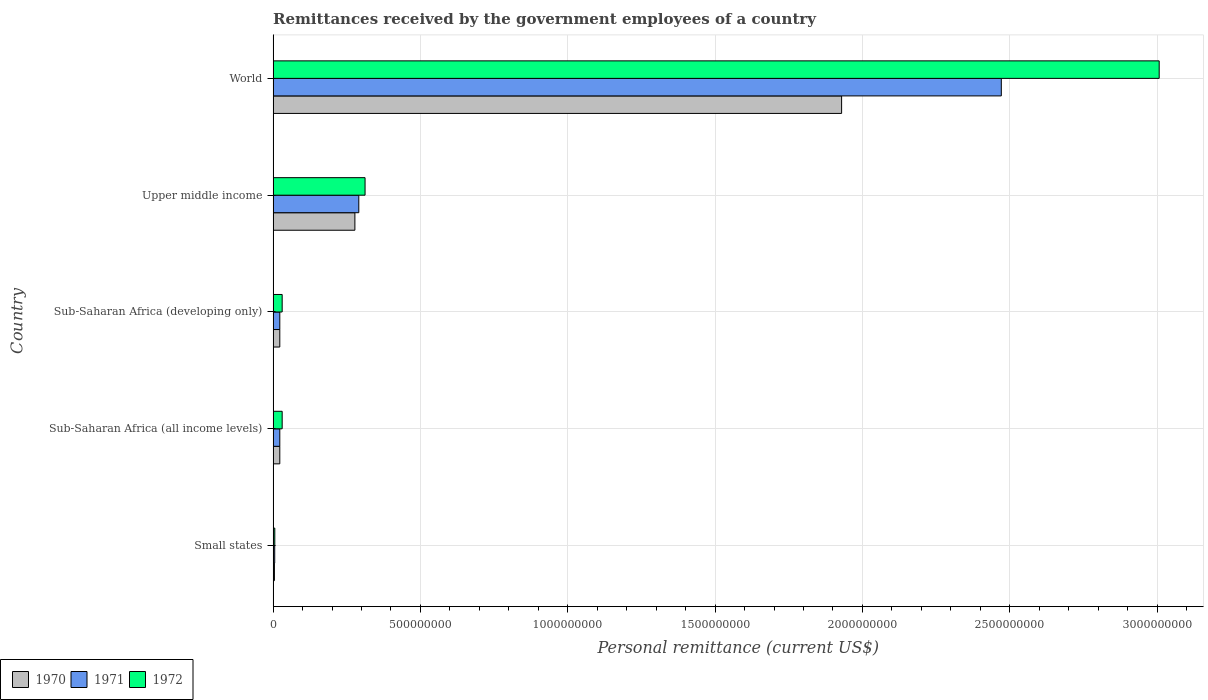How many different coloured bars are there?
Your response must be concise. 3. How many groups of bars are there?
Keep it short and to the point. 5. Are the number of bars per tick equal to the number of legend labels?
Your answer should be compact. Yes. Are the number of bars on each tick of the Y-axis equal?
Your response must be concise. Yes. How many bars are there on the 2nd tick from the bottom?
Give a very brief answer. 3. What is the remittances received by the government employees in 1971 in Upper middle income?
Provide a succinct answer. 2.91e+08. Across all countries, what is the maximum remittances received by the government employees in 1972?
Offer a terse response. 3.01e+09. Across all countries, what is the minimum remittances received by the government employees in 1970?
Make the answer very short. 4.40e+06. In which country was the remittances received by the government employees in 1972 maximum?
Give a very brief answer. World. In which country was the remittances received by the government employees in 1971 minimum?
Give a very brief answer. Small states. What is the total remittances received by the government employees in 1972 in the graph?
Provide a succinct answer. 3.39e+09. What is the difference between the remittances received by the government employees in 1972 in Small states and that in Upper middle income?
Provide a short and direct response. -3.06e+08. What is the difference between the remittances received by the government employees in 1972 in Upper middle income and the remittances received by the government employees in 1970 in Small states?
Offer a very short reply. 3.08e+08. What is the average remittances received by the government employees in 1972 per country?
Keep it short and to the point. 6.77e+08. What is the difference between the remittances received by the government employees in 1970 and remittances received by the government employees in 1971 in Small states?
Offer a terse response. -1.00e+06. What is the ratio of the remittances received by the government employees in 1971 in Upper middle income to that in World?
Keep it short and to the point. 0.12. Is the difference between the remittances received by the government employees in 1970 in Upper middle income and World greater than the difference between the remittances received by the government employees in 1971 in Upper middle income and World?
Provide a succinct answer. Yes. What is the difference between the highest and the second highest remittances received by the government employees in 1970?
Provide a succinct answer. 1.65e+09. What is the difference between the highest and the lowest remittances received by the government employees in 1970?
Give a very brief answer. 1.92e+09. In how many countries, is the remittances received by the government employees in 1970 greater than the average remittances received by the government employees in 1970 taken over all countries?
Provide a short and direct response. 1. Is the sum of the remittances received by the government employees in 1972 in Sub-Saharan Africa (all income levels) and Sub-Saharan Africa (developing only) greater than the maximum remittances received by the government employees in 1970 across all countries?
Offer a very short reply. No. How many bars are there?
Give a very brief answer. 15. How many countries are there in the graph?
Make the answer very short. 5. Does the graph contain any zero values?
Provide a succinct answer. No. Where does the legend appear in the graph?
Provide a short and direct response. Bottom left. How are the legend labels stacked?
Ensure brevity in your answer.  Horizontal. What is the title of the graph?
Give a very brief answer. Remittances received by the government employees of a country. What is the label or title of the X-axis?
Your response must be concise. Personal remittance (current US$). What is the label or title of the Y-axis?
Your answer should be compact. Country. What is the Personal remittance (current US$) in 1970 in Small states?
Provide a short and direct response. 4.40e+06. What is the Personal remittance (current US$) of 1971 in Small states?
Your response must be concise. 5.40e+06. What is the Personal remittance (current US$) of 1972 in Small states?
Provide a short and direct response. 5.71e+06. What is the Personal remittance (current US$) of 1970 in Sub-Saharan Africa (all income levels)?
Offer a very short reply. 2.27e+07. What is the Personal remittance (current US$) in 1971 in Sub-Saharan Africa (all income levels)?
Ensure brevity in your answer.  2.26e+07. What is the Personal remittance (current US$) in 1972 in Sub-Saharan Africa (all income levels)?
Your answer should be compact. 3.07e+07. What is the Personal remittance (current US$) of 1970 in Sub-Saharan Africa (developing only)?
Make the answer very short. 2.27e+07. What is the Personal remittance (current US$) in 1971 in Sub-Saharan Africa (developing only)?
Offer a very short reply. 2.26e+07. What is the Personal remittance (current US$) of 1972 in Sub-Saharan Africa (developing only)?
Your answer should be very brief. 3.07e+07. What is the Personal remittance (current US$) of 1970 in Upper middle income?
Offer a very short reply. 2.77e+08. What is the Personal remittance (current US$) of 1971 in Upper middle income?
Give a very brief answer. 2.91e+08. What is the Personal remittance (current US$) of 1972 in Upper middle income?
Offer a very short reply. 3.12e+08. What is the Personal remittance (current US$) in 1970 in World?
Make the answer very short. 1.93e+09. What is the Personal remittance (current US$) in 1971 in World?
Offer a terse response. 2.47e+09. What is the Personal remittance (current US$) in 1972 in World?
Keep it short and to the point. 3.01e+09. Across all countries, what is the maximum Personal remittance (current US$) in 1970?
Keep it short and to the point. 1.93e+09. Across all countries, what is the maximum Personal remittance (current US$) in 1971?
Your response must be concise. 2.47e+09. Across all countries, what is the maximum Personal remittance (current US$) in 1972?
Ensure brevity in your answer.  3.01e+09. Across all countries, what is the minimum Personal remittance (current US$) in 1970?
Ensure brevity in your answer.  4.40e+06. Across all countries, what is the minimum Personal remittance (current US$) in 1971?
Offer a very short reply. 5.40e+06. Across all countries, what is the minimum Personal remittance (current US$) of 1972?
Keep it short and to the point. 5.71e+06. What is the total Personal remittance (current US$) in 1970 in the graph?
Offer a very short reply. 2.26e+09. What is the total Personal remittance (current US$) of 1971 in the graph?
Your answer should be compact. 2.81e+09. What is the total Personal remittance (current US$) in 1972 in the graph?
Offer a very short reply. 3.39e+09. What is the difference between the Personal remittance (current US$) in 1970 in Small states and that in Sub-Saharan Africa (all income levels)?
Provide a succinct answer. -1.83e+07. What is the difference between the Personal remittance (current US$) of 1971 in Small states and that in Sub-Saharan Africa (all income levels)?
Ensure brevity in your answer.  -1.72e+07. What is the difference between the Personal remittance (current US$) in 1972 in Small states and that in Sub-Saharan Africa (all income levels)?
Your answer should be compact. -2.50e+07. What is the difference between the Personal remittance (current US$) of 1970 in Small states and that in Sub-Saharan Africa (developing only)?
Make the answer very short. -1.83e+07. What is the difference between the Personal remittance (current US$) in 1971 in Small states and that in Sub-Saharan Africa (developing only)?
Offer a very short reply. -1.72e+07. What is the difference between the Personal remittance (current US$) in 1972 in Small states and that in Sub-Saharan Africa (developing only)?
Provide a short and direct response. -2.50e+07. What is the difference between the Personal remittance (current US$) in 1970 in Small states and that in Upper middle income?
Offer a terse response. -2.73e+08. What is the difference between the Personal remittance (current US$) of 1971 in Small states and that in Upper middle income?
Provide a short and direct response. -2.85e+08. What is the difference between the Personal remittance (current US$) in 1972 in Small states and that in Upper middle income?
Offer a very short reply. -3.06e+08. What is the difference between the Personal remittance (current US$) in 1970 in Small states and that in World?
Offer a very short reply. -1.92e+09. What is the difference between the Personal remittance (current US$) of 1971 in Small states and that in World?
Provide a short and direct response. -2.47e+09. What is the difference between the Personal remittance (current US$) in 1972 in Small states and that in World?
Provide a short and direct response. -3.00e+09. What is the difference between the Personal remittance (current US$) in 1970 in Sub-Saharan Africa (all income levels) and that in Sub-Saharan Africa (developing only)?
Offer a terse response. 0. What is the difference between the Personal remittance (current US$) in 1971 in Sub-Saharan Africa (all income levels) and that in Sub-Saharan Africa (developing only)?
Keep it short and to the point. 0. What is the difference between the Personal remittance (current US$) in 1972 in Sub-Saharan Africa (all income levels) and that in Sub-Saharan Africa (developing only)?
Make the answer very short. 0. What is the difference between the Personal remittance (current US$) of 1970 in Sub-Saharan Africa (all income levels) and that in Upper middle income?
Make the answer very short. -2.55e+08. What is the difference between the Personal remittance (current US$) in 1971 in Sub-Saharan Africa (all income levels) and that in Upper middle income?
Your answer should be compact. -2.68e+08. What is the difference between the Personal remittance (current US$) of 1972 in Sub-Saharan Africa (all income levels) and that in Upper middle income?
Keep it short and to the point. -2.81e+08. What is the difference between the Personal remittance (current US$) of 1970 in Sub-Saharan Africa (all income levels) and that in World?
Give a very brief answer. -1.91e+09. What is the difference between the Personal remittance (current US$) in 1971 in Sub-Saharan Africa (all income levels) and that in World?
Your answer should be compact. -2.45e+09. What is the difference between the Personal remittance (current US$) in 1972 in Sub-Saharan Africa (all income levels) and that in World?
Offer a very short reply. -2.98e+09. What is the difference between the Personal remittance (current US$) in 1970 in Sub-Saharan Africa (developing only) and that in Upper middle income?
Ensure brevity in your answer.  -2.55e+08. What is the difference between the Personal remittance (current US$) in 1971 in Sub-Saharan Africa (developing only) and that in Upper middle income?
Make the answer very short. -2.68e+08. What is the difference between the Personal remittance (current US$) of 1972 in Sub-Saharan Africa (developing only) and that in Upper middle income?
Provide a succinct answer. -2.81e+08. What is the difference between the Personal remittance (current US$) in 1970 in Sub-Saharan Africa (developing only) and that in World?
Keep it short and to the point. -1.91e+09. What is the difference between the Personal remittance (current US$) of 1971 in Sub-Saharan Africa (developing only) and that in World?
Provide a succinct answer. -2.45e+09. What is the difference between the Personal remittance (current US$) in 1972 in Sub-Saharan Africa (developing only) and that in World?
Provide a short and direct response. -2.98e+09. What is the difference between the Personal remittance (current US$) in 1970 in Upper middle income and that in World?
Offer a terse response. -1.65e+09. What is the difference between the Personal remittance (current US$) of 1971 in Upper middle income and that in World?
Your response must be concise. -2.18e+09. What is the difference between the Personal remittance (current US$) in 1972 in Upper middle income and that in World?
Ensure brevity in your answer.  -2.70e+09. What is the difference between the Personal remittance (current US$) in 1970 in Small states and the Personal remittance (current US$) in 1971 in Sub-Saharan Africa (all income levels)?
Offer a very short reply. -1.82e+07. What is the difference between the Personal remittance (current US$) of 1970 in Small states and the Personal remittance (current US$) of 1972 in Sub-Saharan Africa (all income levels)?
Your answer should be very brief. -2.63e+07. What is the difference between the Personal remittance (current US$) of 1971 in Small states and the Personal remittance (current US$) of 1972 in Sub-Saharan Africa (all income levels)?
Ensure brevity in your answer.  -2.53e+07. What is the difference between the Personal remittance (current US$) of 1970 in Small states and the Personal remittance (current US$) of 1971 in Sub-Saharan Africa (developing only)?
Provide a succinct answer. -1.82e+07. What is the difference between the Personal remittance (current US$) in 1970 in Small states and the Personal remittance (current US$) in 1972 in Sub-Saharan Africa (developing only)?
Offer a terse response. -2.63e+07. What is the difference between the Personal remittance (current US$) in 1971 in Small states and the Personal remittance (current US$) in 1972 in Sub-Saharan Africa (developing only)?
Ensure brevity in your answer.  -2.53e+07. What is the difference between the Personal remittance (current US$) of 1970 in Small states and the Personal remittance (current US$) of 1971 in Upper middle income?
Your response must be concise. -2.86e+08. What is the difference between the Personal remittance (current US$) in 1970 in Small states and the Personal remittance (current US$) in 1972 in Upper middle income?
Your answer should be very brief. -3.08e+08. What is the difference between the Personal remittance (current US$) in 1971 in Small states and the Personal remittance (current US$) in 1972 in Upper middle income?
Keep it short and to the point. -3.07e+08. What is the difference between the Personal remittance (current US$) in 1970 in Small states and the Personal remittance (current US$) in 1971 in World?
Your answer should be compact. -2.47e+09. What is the difference between the Personal remittance (current US$) of 1970 in Small states and the Personal remittance (current US$) of 1972 in World?
Provide a short and direct response. -3.00e+09. What is the difference between the Personal remittance (current US$) in 1971 in Small states and the Personal remittance (current US$) in 1972 in World?
Your answer should be compact. -3.00e+09. What is the difference between the Personal remittance (current US$) in 1970 in Sub-Saharan Africa (all income levels) and the Personal remittance (current US$) in 1971 in Sub-Saharan Africa (developing only)?
Your answer should be compact. 2.18e+04. What is the difference between the Personal remittance (current US$) in 1970 in Sub-Saharan Africa (all income levels) and the Personal remittance (current US$) in 1972 in Sub-Saharan Africa (developing only)?
Give a very brief answer. -8.07e+06. What is the difference between the Personal remittance (current US$) of 1971 in Sub-Saharan Africa (all income levels) and the Personal remittance (current US$) of 1972 in Sub-Saharan Africa (developing only)?
Offer a very short reply. -8.09e+06. What is the difference between the Personal remittance (current US$) of 1970 in Sub-Saharan Africa (all income levels) and the Personal remittance (current US$) of 1971 in Upper middle income?
Your response must be concise. -2.68e+08. What is the difference between the Personal remittance (current US$) of 1970 in Sub-Saharan Africa (all income levels) and the Personal remittance (current US$) of 1972 in Upper middle income?
Give a very brief answer. -2.89e+08. What is the difference between the Personal remittance (current US$) of 1971 in Sub-Saharan Africa (all income levels) and the Personal remittance (current US$) of 1972 in Upper middle income?
Offer a terse response. -2.89e+08. What is the difference between the Personal remittance (current US$) of 1970 in Sub-Saharan Africa (all income levels) and the Personal remittance (current US$) of 1971 in World?
Ensure brevity in your answer.  -2.45e+09. What is the difference between the Personal remittance (current US$) of 1970 in Sub-Saharan Africa (all income levels) and the Personal remittance (current US$) of 1972 in World?
Offer a terse response. -2.98e+09. What is the difference between the Personal remittance (current US$) of 1971 in Sub-Saharan Africa (all income levels) and the Personal remittance (current US$) of 1972 in World?
Provide a succinct answer. -2.98e+09. What is the difference between the Personal remittance (current US$) of 1970 in Sub-Saharan Africa (developing only) and the Personal remittance (current US$) of 1971 in Upper middle income?
Keep it short and to the point. -2.68e+08. What is the difference between the Personal remittance (current US$) in 1970 in Sub-Saharan Africa (developing only) and the Personal remittance (current US$) in 1972 in Upper middle income?
Make the answer very short. -2.89e+08. What is the difference between the Personal remittance (current US$) of 1971 in Sub-Saharan Africa (developing only) and the Personal remittance (current US$) of 1972 in Upper middle income?
Ensure brevity in your answer.  -2.89e+08. What is the difference between the Personal remittance (current US$) of 1970 in Sub-Saharan Africa (developing only) and the Personal remittance (current US$) of 1971 in World?
Your answer should be compact. -2.45e+09. What is the difference between the Personal remittance (current US$) in 1970 in Sub-Saharan Africa (developing only) and the Personal remittance (current US$) in 1972 in World?
Offer a very short reply. -2.98e+09. What is the difference between the Personal remittance (current US$) in 1971 in Sub-Saharan Africa (developing only) and the Personal remittance (current US$) in 1972 in World?
Ensure brevity in your answer.  -2.98e+09. What is the difference between the Personal remittance (current US$) in 1970 in Upper middle income and the Personal remittance (current US$) in 1971 in World?
Your answer should be very brief. -2.19e+09. What is the difference between the Personal remittance (current US$) in 1970 in Upper middle income and the Personal remittance (current US$) in 1972 in World?
Provide a short and direct response. -2.73e+09. What is the difference between the Personal remittance (current US$) of 1971 in Upper middle income and the Personal remittance (current US$) of 1972 in World?
Keep it short and to the point. -2.72e+09. What is the average Personal remittance (current US$) of 1970 per country?
Your answer should be compact. 4.51e+08. What is the average Personal remittance (current US$) of 1971 per country?
Ensure brevity in your answer.  5.63e+08. What is the average Personal remittance (current US$) of 1972 per country?
Your answer should be very brief. 6.77e+08. What is the difference between the Personal remittance (current US$) of 1970 and Personal remittance (current US$) of 1971 in Small states?
Give a very brief answer. -1.00e+06. What is the difference between the Personal remittance (current US$) in 1970 and Personal remittance (current US$) in 1972 in Small states?
Offer a terse response. -1.31e+06. What is the difference between the Personal remittance (current US$) of 1971 and Personal remittance (current US$) of 1972 in Small states?
Your answer should be compact. -3.07e+05. What is the difference between the Personal remittance (current US$) in 1970 and Personal remittance (current US$) in 1971 in Sub-Saharan Africa (all income levels)?
Offer a terse response. 2.18e+04. What is the difference between the Personal remittance (current US$) in 1970 and Personal remittance (current US$) in 1972 in Sub-Saharan Africa (all income levels)?
Offer a terse response. -8.07e+06. What is the difference between the Personal remittance (current US$) in 1971 and Personal remittance (current US$) in 1972 in Sub-Saharan Africa (all income levels)?
Offer a terse response. -8.09e+06. What is the difference between the Personal remittance (current US$) in 1970 and Personal remittance (current US$) in 1971 in Sub-Saharan Africa (developing only)?
Your response must be concise. 2.18e+04. What is the difference between the Personal remittance (current US$) in 1970 and Personal remittance (current US$) in 1972 in Sub-Saharan Africa (developing only)?
Give a very brief answer. -8.07e+06. What is the difference between the Personal remittance (current US$) in 1971 and Personal remittance (current US$) in 1972 in Sub-Saharan Africa (developing only)?
Provide a succinct answer. -8.09e+06. What is the difference between the Personal remittance (current US$) in 1970 and Personal remittance (current US$) in 1971 in Upper middle income?
Your answer should be compact. -1.32e+07. What is the difference between the Personal remittance (current US$) in 1970 and Personal remittance (current US$) in 1972 in Upper middle income?
Your answer should be compact. -3.45e+07. What is the difference between the Personal remittance (current US$) of 1971 and Personal remittance (current US$) of 1972 in Upper middle income?
Offer a very short reply. -2.13e+07. What is the difference between the Personal remittance (current US$) of 1970 and Personal remittance (current US$) of 1971 in World?
Your answer should be very brief. -5.42e+08. What is the difference between the Personal remittance (current US$) of 1970 and Personal remittance (current US$) of 1972 in World?
Keep it short and to the point. -1.08e+09. What is the difference between the Personal remittance (current US$) of 1971 and Personal remittance (current US$) of 1972 in World?
Your answer should be very brief. -5.36e+08. What is the ratio of the Personal remittance (current US$) of 1970 in Small states to that in Sub-Saharan Africa (all income levels)?
Provide a short and direct response. 0.19. What is the ratio of the Personal remittance (current US$) in 1971 in Small states to that in Sub-Saharan Africa (all income levels)?
Offer a very short reply. 0.24. What is the ratio of the Personal remittance (current US$) in 1972 in Small states to that in Sub-Saharan Africa (all income levels)?
Ensure brevity in your answer.  0.19. What is the ratio of the Personal remittance (current US$) of 1970 in Small states to that in Sub-Saharan Africa (developing only)?
Your answer should be very brief. 0.19. What is the ratio of the Personal remittance (current US$) of 1971 in Small states to that in Sub-Saharan Africa (developing only)?
Provide a succinct answer. 0.24. What is the ratio of the Personal remittance (current US$) of 1972 in Small states to that in Sub-Saharan Africa (developing only)?
Offer a very short reply. 0.19. What is the ratio of the Personal remittance (current US$) in 1970 in Small states to that in Upper middle income?
Offer a terse response. 0.02. What is the ratio of the Personal remittance (current US$) in 1971 in Small states to that in Upper middle income?
Your answer should be compact. 0.02. What is the ratio of the Personal remittance (current US$) in 1972 in Small states to that in Upper middle income?
Provide a succinct answer. 0.02. What is the ratio of the Personal remittance (current US$) of 1970 in Small states to that in World?
Your answer should be compact. 0. What is the ratio of the Personal remittance (current US$) of 1971 in Small states to that in World?
Make the answer very short. 0. What is the ratio of the Personal remittance (current US$) in 1972 in Small states to that in World?
Give a very brief answer. 0. What is the ratio of the Personal remittance (current US$) of 1970 in Sub-Saharan Africa (all income levels) to that in Upper middle income?
Provide a succinct answer. 0.08. What is the ratio of the Personal remittance (current US$) in 1971 in Sub-Saharan Africa (all income levels) to that in Upper middle income?
Your answer should be very brief. 0.08. What is the ratio of the Personal remittance (current US$) in 1972 in Sub-Saharan Africa (all income levels) to that in Upper middle income?
Keep it short and to the point. 0.1. What is the ratio of the Personal remittance (current US$) in 1970 in Sub-Saharan Africa (all income levels) to that in World?
Ensure brevity in your answer.  0.01. What is the ratio of the Personal remittance (current US$) in 1971 in Sub-Saharan Africa (all income levels) to that in World?
Give a very brief answer. 0.01. What is the ratio of the Personal remittance (current US$) of 1972 in Sub-Saharan Africa (all income levels) to that in World?
Provide a succinct answer. 0.01. What is the ratio of the Personal remittance (current US$) in 1970 in Sub-Saharan Africa (developing only) to that in Upper middle income?
Provide a short and direct response. 0.08. What is the ratio of the Personal remittance (current US$) in 1971 in Sub-Saharan Africa (developing only) to that in Upper middle income?
Offer a very short reply. 0.08. What is the ratio of the Personal remittance (current US$) of 1972 in Sub-Saharan Africa (developing only) to that in Upper middle income?
Provide a succinct answer. 0.1. What is the ratio of the Personal remittance (current US$) in 1970 in Sub-Saharan Africa (developing only) to that in World?
Give a very brief answer. 0.01. What is the ratio of the Personal remittance (current US$) in 1971 in Sub-Saharan Africa (developing only) to that in World?
Provide a succinct answer. 0.01. What is the ratio of the Personal remittance (current US$) of 1972 in Sub-Saharan Africa (developing only) to that in World?
Give a very brief answer. 0.01. What is the ratio of the Personal remittance (current US$) of 1970 in Upper middle income to that in World?
Offer a very short reply. 0.14. What is the ratio of the Personal remittance (current US$) in 1971 in Upper middle income to that in World?
Your answer should be very brief. 0.12. What is the ratio of the Personal remittance (current US$) of 1972 in Upper middle income to that in World?
Provide a succinct answer. 0.1. What is the difference between the highest and the second highest Personal remittance (current US$) of 1970?
Provide a short and direct response. 1.65e+09. What is the difference between the highest and the second highest Personal remittance (current US$) of 1971?
Keep it short and to the point. 2.18e+09. What is the difference between the highest and the second highest Personal remittance (current US$) of 1972?
Your answer should be compact. 2.70e+09. What is the difference between the highest and the lowest Personal remittance (current US$) in 1970?
Offer a very short reply. 1.92e+09. What is the difference between the highest and the lowest Personal remittance (current US$) of 1971?
Keep it short and to the point. 2.47e+09. What is the difference between the highest and the lowest Personal remittance (current US$) in 1972?
Offer a terse response. 3.00e+09. 